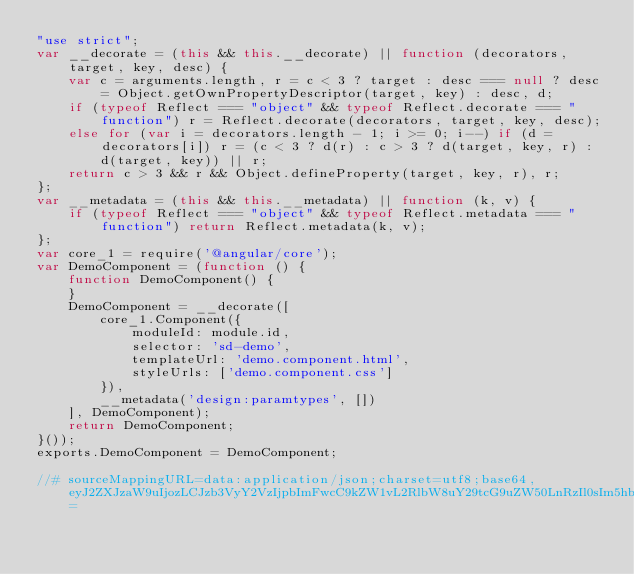Convert code to text. <code><loc_0><loc_0><loc_500><loc_500><_JavaScript_>"use strict";
var __decorate = (this && this.__decorate) || function (decorators, target, key, desc) {
    var c = arguments.length, r = c < 3 ? target : desc === null ? desc = Object.getOwnPropertyDescriptor(target, key) : desc, d;
    if (typeof Reflect === "object" && typeof Reflect.decorate === "function") r = Reflect.decorate(decorators, target, key, desc);
    else for (var i = decorators.length - 1; i >= 0; i--) if (d = decorators[i]) r = (c < 3 ? d(r) : c > 3 ? d(target, key, r) : d(target, key)) || r;
    return c > 3 && r && Object.defineProperty(target, key, r), r;
};
var __metadata = (this && this.__metadata) || function (k, v) {
    if (typeof Reflect === "object" && typeof Reflect.metadata === "function") return Reflect.metadata(k, v);
};
var core_1 = require('@angular/core');
var DemoComponent = (function () {
    function DemoComponent() {
    }
    DemoComponent = __decorate([
        core_1.Component({
            moduleId: module.id,
            selector: 'sd-demo',
            templateUrl: 'demo.component.html',
            styleUrls: ['demo.component.css']
        }), 
        __metadata('design:paramtypes', [])
    ], DemoComponent);
    return DemoComponent;
}());
exports.DemoComponent = DemoComponent;

//# sourceMappingURL=data:application/json;charset=utf8;base64,eyJ2ZXJzaW9uIjozLCJzb3VyY2VzIjpbImFwcC9kZW1vL2RlbW8uY29tcG9uZW50LnRzIl0sIm5hbWVzIjpbXSwibWFwcGluZ3MiOiI7Ozs7Ozs7Ozs7QUFBQSxxQkFBMEIsZUFBZSxDQUFDLENBQUE7QUFXMUM7SUFBQTtJQUE2QixDQUFDO0lBTjlCO1FBQUMsZ0JBQVMsQ0FBQztZQUNULFFBQVEsRUFBRSxNQUFNLENBQUMsRUFBRTtZQUNuQixRQUFRLEVBQUUsU0FBUztZQUNuQixXQUFXLEVBQUUscUJBQXFCO1lBQ2xDLFNBQVMsRUFBRSxDQUFDLG9CQUFvQixDQUFDO1NBQ2xDLENBQUM7O3FCQUFBO0lBQzJCLG9CQUFDO0FBQUQsQ0FBN0IsQUFBOEIsSUFBQTtBQUFqQixxQkFBYSxnQkFBSSxDQUFBIiwiZmlsZSI6ImFwcC9kZW1vL2RlbW8uY29tcG9uZW50LmpzIiwic291cmNlc0NvbnRlbnQiOlsiaW1wb3J0IHsgQ29tcG9uZW50IH0gZnJvbSAnQGFuZ3VsYXIvY29yZSc7XG5cbi8qKlxuICogVGhpcyBjbGFzcyByZXByZXNlbnRzIHRoZSBsYXp5IGxvYWRlZCBEZW1vQ29tcG9uZW50LlxuICovXG5AQ29tcG9uZW50KHtcbiAgbW9kdWxlSWQ6IG1vZHVsZS5pZCxcbiAgc2VsZWN0b3I6ICdzZC1kZW1vJyxcbiAgdGVtcGxhdGVVcmw6ICdkZW1vLmNvbXBvbmVudC5odG1sJyxcbiAgc3R5bGVVcmxzOiBbJ2RlbW8uY29tcG9uZW50LmNzcyddXG59KVxuZXhwb3J0IGNsYXNzIERlbW9Db21wb25lbnQgeyB9XG4iXX0=
</code> 